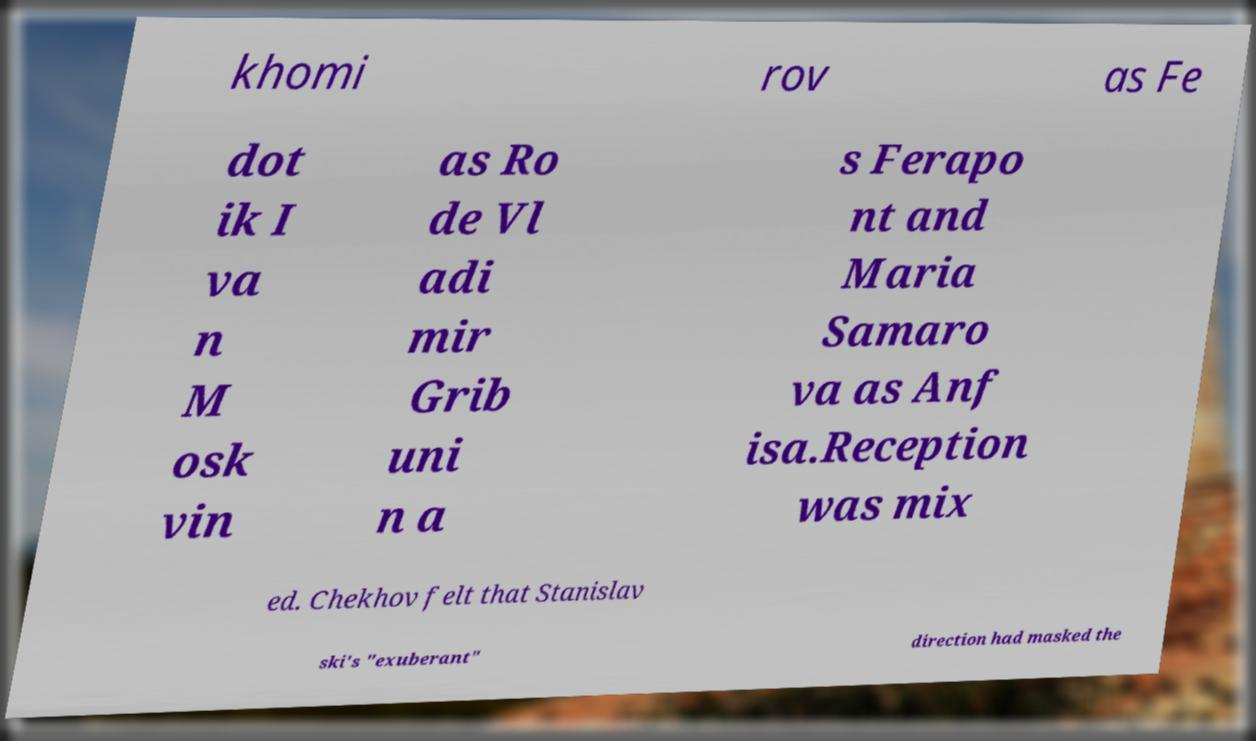Can you read and provide the text displayed in the image?This photo seems to have some interesting text. Can you extract and type it out for me? khomi rov as Fe dot ik I va n M osk vin as Ro de Vl adi mir Grib uni n a s Ferapo nt and Maria Samaro va as Anf isa.Reception was mix ed. Chekhov felt that Stanislav ski's "exuberant" direction had masked the 